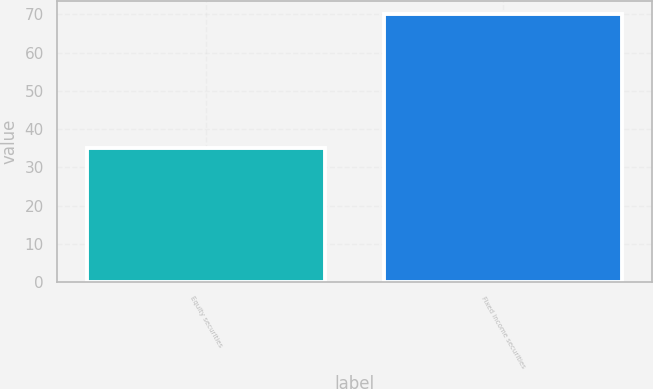Convert chart to OTSL. <chart><loc_0><loc_0><loc_500><loc_500><bar_chart><fcel>Equity securities<fcel>Fixed income securities<nl><fcel>35<fcel>70<nl></chart> 